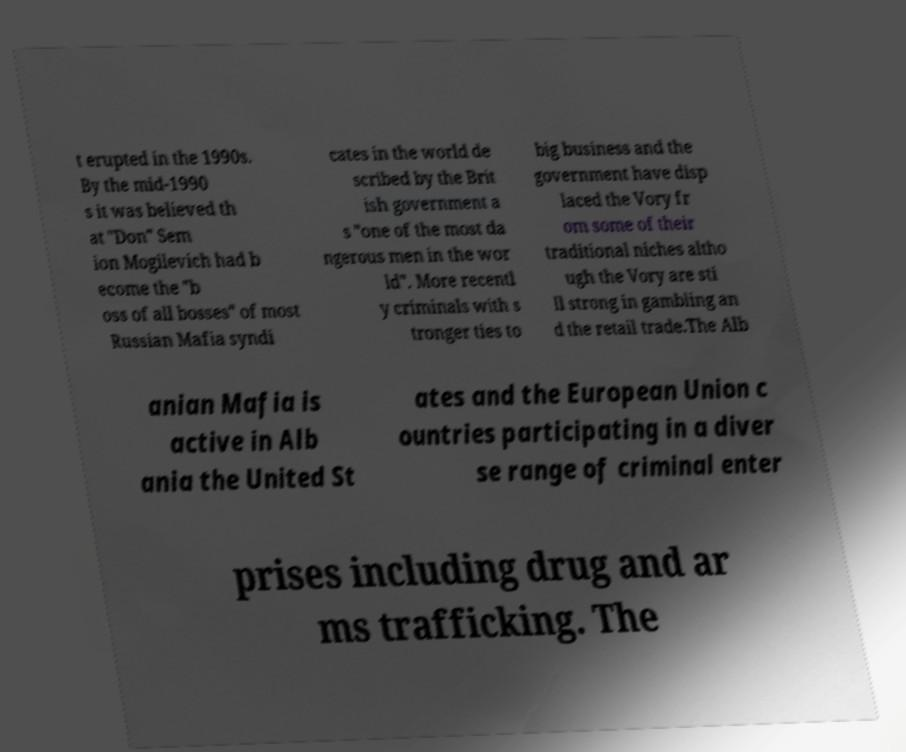Please identify and transcribe the text found in this image. t erupted in the 1990s. By the mid-1990 s it was believed th at "Don" Sem ion Mogilevich had b ecome the "b oss of all bosses" of most Russian Mafia syndi cates in the world de scribed by the Brit ish government a s "one of the most da ngerous men in the wor ld". More recentl y criminals with s tronger ties to big business and the government have disp laced the Vory fr om some of their traditional niches altho ugh the Vory are sti ll strong in gambling an d the retail trade.The Alb anian Mafia is active in Alb ania the United St ates and the European Union c ountries participating in a diver se range of criminal enter prises including drug and ar ms trafficking. The 